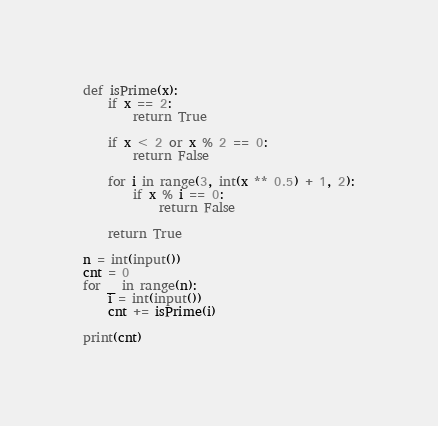<code> <loc_0><loc_0><loc_500><loc_500><_Python_>def isPrime(x):
    if x == 2:
        return True

    if x < 2 or x % 2 == 0:
        return False

    for i in range(3, int(x ** 0.5) + 1, 2):
        if x % i == 0:
            return False

    return True

n = int(input())
cnt = 0
for _ in range(n):
    i = int(input())
    cnt += isPrime(i)

print(cnt)
</code> 